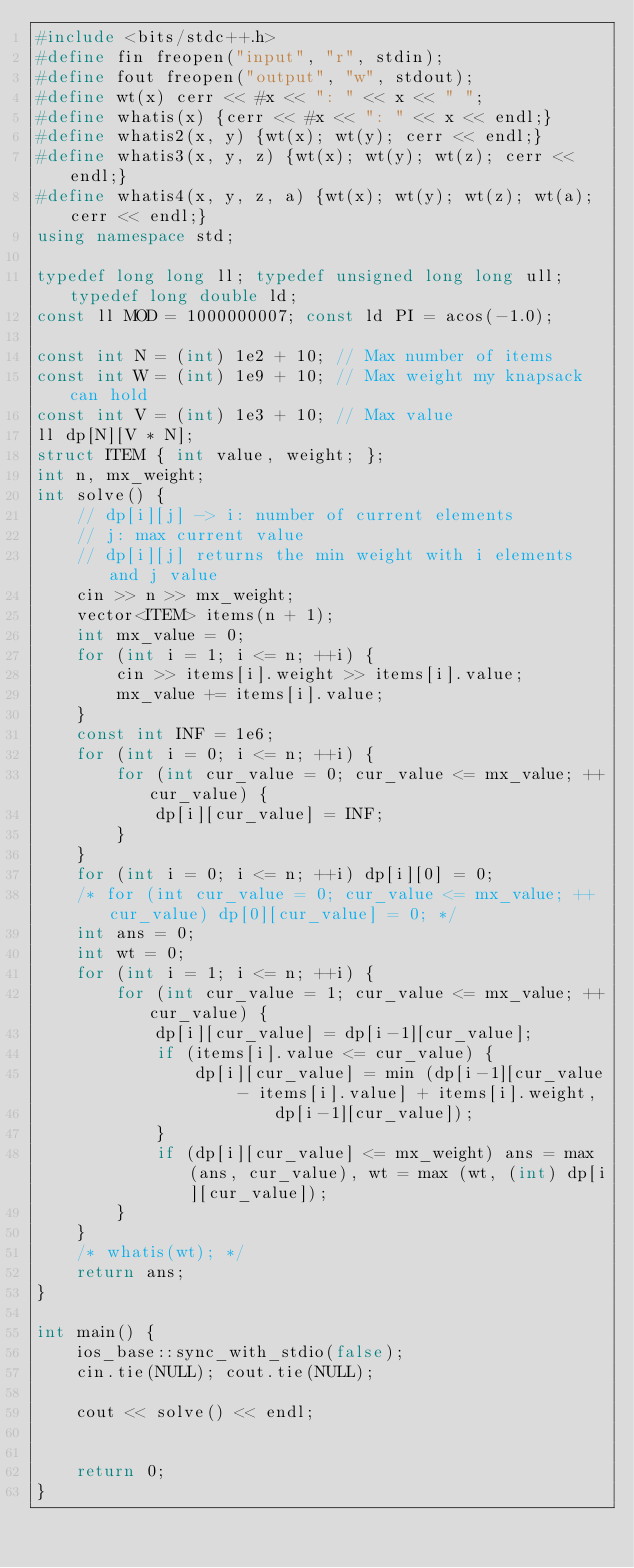Convert code to text. <code><loc_0><loc_0><loc_500><loc_500><_C++_>#include <bits/stdc++.h>
#define fin freopen("input", "r", stdin);
#define fout freopen("output", "w", stdout);
#define wt(x) cerr << #x << ": " << x << " ";
#define whatis(x) {cerr << #x << ": " << x << endl;}
#define whatis2(x, y) {wt(x); wt(y); cerr << endl;}
#define whatis3(x, y, z) {wt(x); wt(y); wt(z); cerr << endl;}
#define whatis4(x, y, z, a) {wt(x); wt(y); wt(z); wt(a); cerr << endl;}
using namespace std;

typedef long long ll; typedef unsigned long long ull; typedef long double ld;
const ll MOD = 1000000007; const ld PI = acos(-1.0);

const int N = (int) 1e2 + 10; // Max number of items
const int W = (int) 1e9 + 10; // Max weight my knapsack can hold
const int V = (int) 1e3 + 10; // Max value
ll dp[N][V * N];
struct ITEM { int value, weight; };
int n, mx_weight;
int solve() {
    // dp[i][j] -> i: number of current elements
    // j: max current value
    // dp[i][j] returns the min weight with i elements and j value
    cin >> n >> mx_weight;
    vector<ITEM> items(n + 1);
    int mx_value = 0;
    for (int i = 1; i <= n; ++i) {
        cin >> items[i].weight >> items[i].value;
        mx_value += items[i].value;
    }
    const int INF = 1e6;
    for (int i = 0; i <= n; ++i) {
        for (int cur_value = 0; cur_value <= mx_value; ++cur_value) {
            dp[i][cur_value] = INF;
        }
    }
    for (int i = 0; i <= n; ++i) dp[i][0] = 0;
    /* for (int cur_value = 0; cur_value <= mx_value; ++cur_value) dp[0][cur_value] = 0; */
    int ans = 0;
    int wt = 0;
    for (int i = 1; i <= n; ++i) {
        for (int cur_value = 1; cur_value <= mx_value; ++cur_value) {
            dp[i][cur_value] = dp[i-1][cur_value];
            if (items[i].value <= cur_value) {
                dp[i][cur_value] = min (dp[i-1][cur_value - items[i].value] + items[i].weight,
                        dp[i-1][cur_value]);
            }
            if (dp[i][cur_value] <= mx_weight) ans = max (ans, cur_value), wt = max (wt, (int) dp[i][cur_value]);
        }
    }
    /* whatis(wt); */
    return ans;
}

int main() {
    ios_base::sync_with_stdio(false);
    cin.tie(NULL); cout.tie(NULL);

    cout << solve() << endl;


    return 0;
}
</code> 